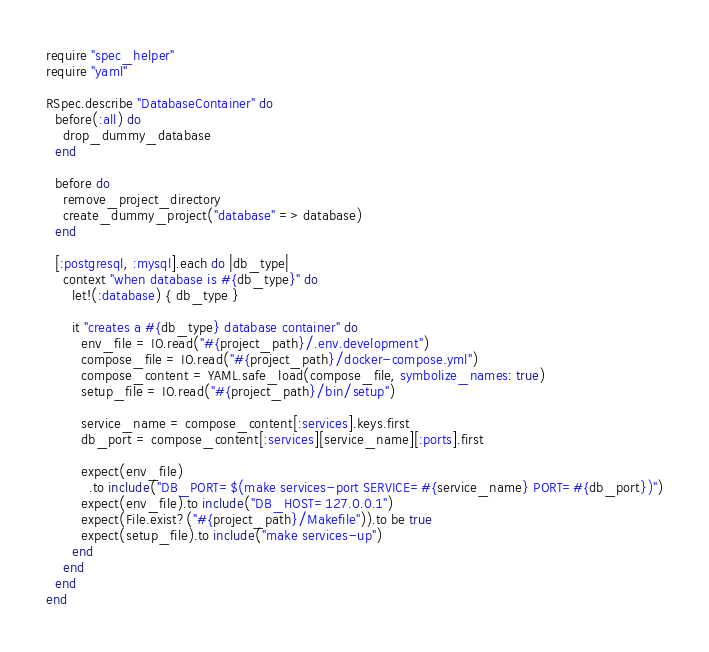Convert code to text. <code><loc_0><loc_0><loc_500><loc_500><_Ruby_>require "spec_helper"
require "yaml"

RSpec.describe "DatabaseContainer" do
  before(:all) do
    drop_dummy_database
  end

  before do
    remove_project_directory
    create_dummy_project("database" => database)
  end

  [:postgresql, :mysql].each do |db_type|
    context "when database is #{db_type}" do
      let!(:database) { db_type }

      it "creates a #{db_type} database container" do
        env_file = IO.read("#{project_path}/.env.development")
        compose_file = IO.read("#{project_path}/docker-compose.yml")
        compose_content = YAML.safe_load(compose_file, symbolize_names: true)
        setup_file = IO.read("#{project_path}/bin/setup")

        service_name = compose_content[:services].keys.first
        db_port = compose_content[:services][service_name][:ports].first

        expect(env_file)
          .to include("DB_PORT=$(make services-port SERVICE=#{service_name} PORT=#{db_port})")
        expect(env_file).to include("DB_HOST=127.0.0.1")
        expect(File.exist?("#{project_path}/Makefile")).to be true
        expect(setup_file).to include("make services-up")
      end
    end
  end
end
</code> 